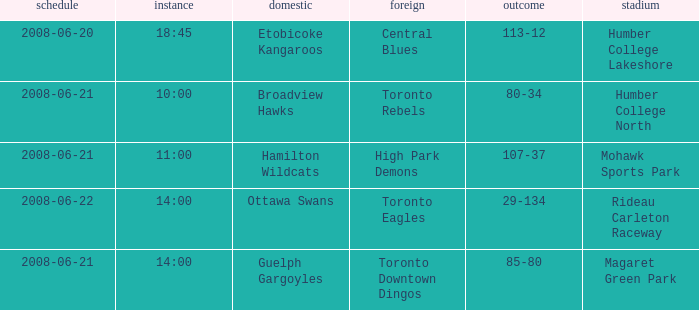What is the Away with a Ground that is humber college north? Toronto Rebels. 